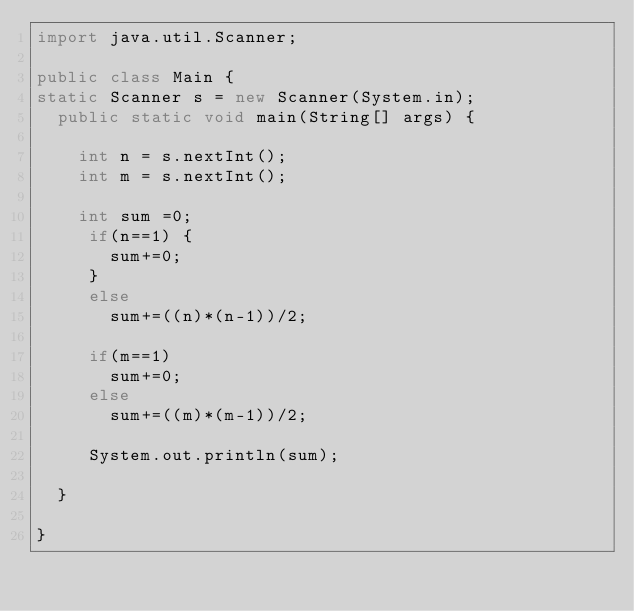<code> <loc_0><loc_0><loc_500><loc_500><_Java_>import java.util.Scanner;

public class Main {
static Scanner s = new Scanner(System.in);
	public static void main(String[] args) {

		int n = s.nextInt();
		int m = s.nextInt();
		
		int sum =0;
		 if(n==1) {
			 sum+=0;
		 }
		 else
			 sum+=((n)*(n-1))/2;
		 
		 if(m==1)
			 sum+=0;
		 else
			 sum+=((m)*(m-1))/2;
		 
		 System.out.println(sum);

	}

}
</code> 